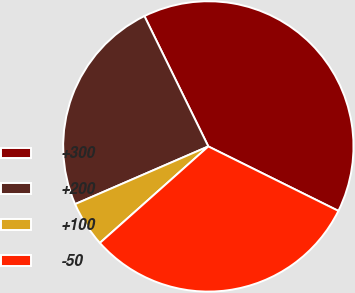<chart> <loc_0><loc_0><loc_500><loc_500><pie_chart><fcel>+300<fcel>+200<fcel>+100<fcel>-50<nl><fcel>39.58%<fcel>24.25%<fcel>5.07%<fcel>31.1%<nl></chart> 